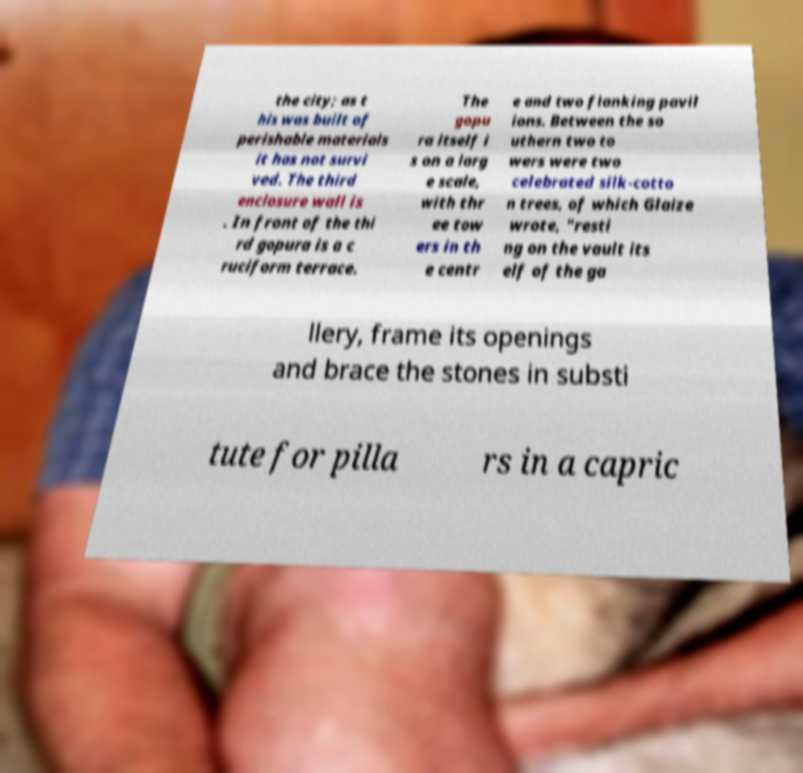What messages or text are displayed in this image? I need them in a readable, typed format. the city; as t his was built of perishable materials it has not survi ved. The third enclosure wall is . In front of the thi rd gopura is a c ruciform terrace. The gopu ra itself i s on a larg e scale, with thr ee tow ers in th e centr e and two flanking pavil ions. Between the so uthern two to wers were two celebrated silk-cotto n trees, of which Glaize wrote, "resti ng on the vault its elf of the ga llery, frame its openings and brace the stones in substi tute for pilla rs in a capric 